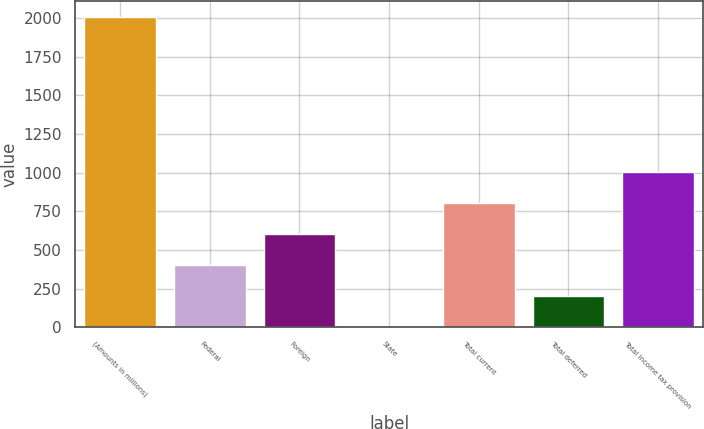Convert chart. <chart><loc_0><loc_0><loc_500><loc_500><bar_chart><fcel>(Amounts in millions)<fcel>Federal<fcel>Foreign<fcel>State<fcel>Total current<fcel>Total deferred<fcel>Total income tax provision<nl><fcel>2007<fcel>405.4<fcel>605.6<fcel>5<fcel>805.8<fcel>205.2<fcel>1006<nl></chart> 